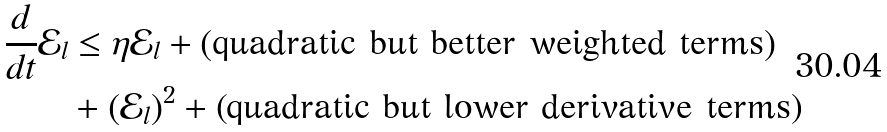Convert formula to latex. <formula><loc_0><loc_0><loc_500><loc_500>\frac { d } { d t } \mathcal { E } _ { l } & \leq \eta \mathcal { E } _ { l } + ( \text {quadratic but better weighted terms} ) \\ & + ( \mathcal { E } _ { l } ) ^ { 2 } + \text {(quadratic but lower derivative terms)}</formula> 